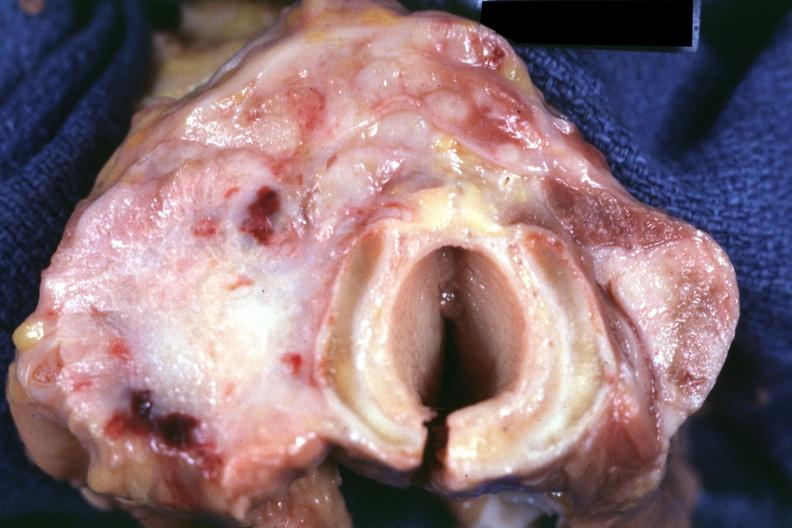what is present?
Answer the question using a single word or phrase. Thyroid 